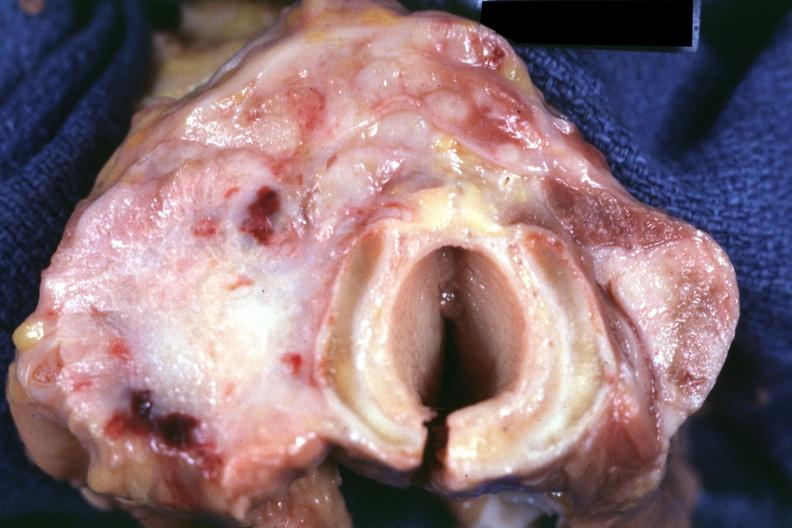what is present?
Answer the question using a single word or phrase. Thyroid 